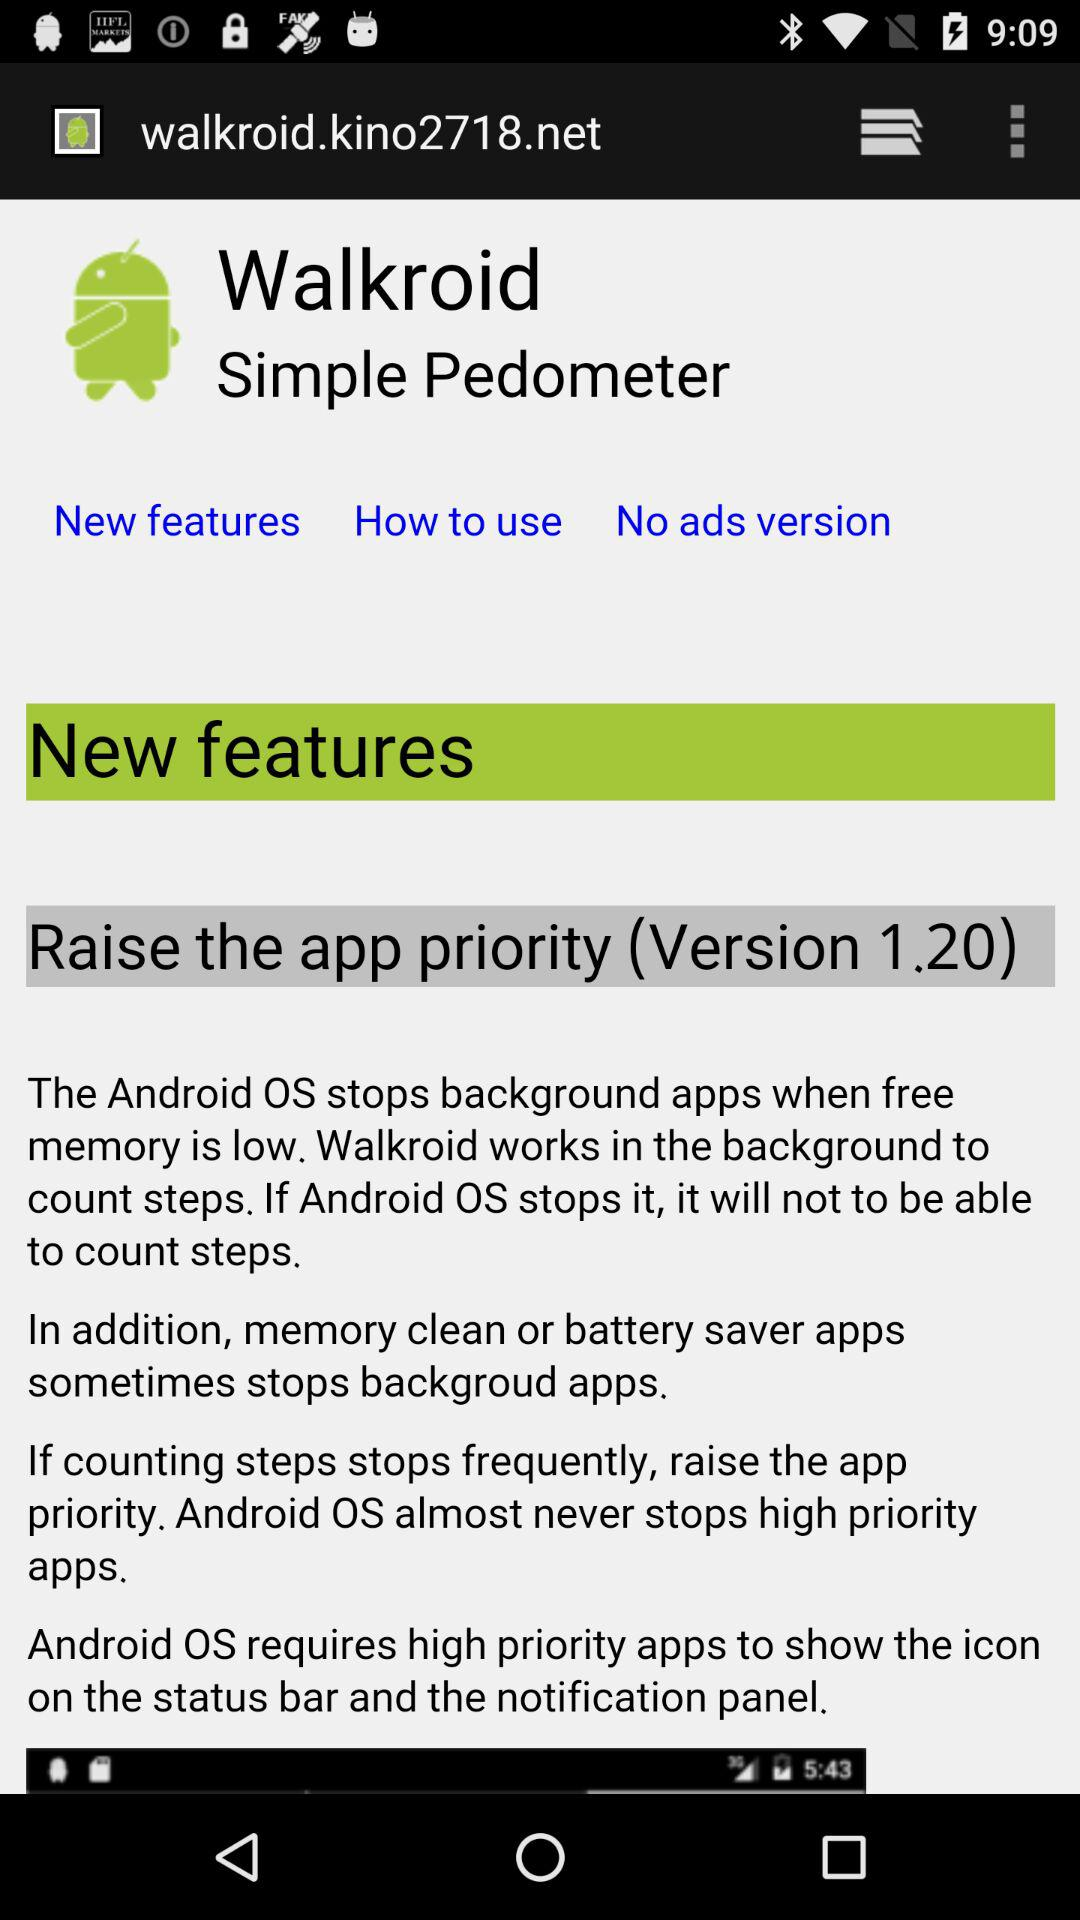Is "New features" selected or not selected?
When the provided information is insufficient, respond with <no answer>. <no answer> 